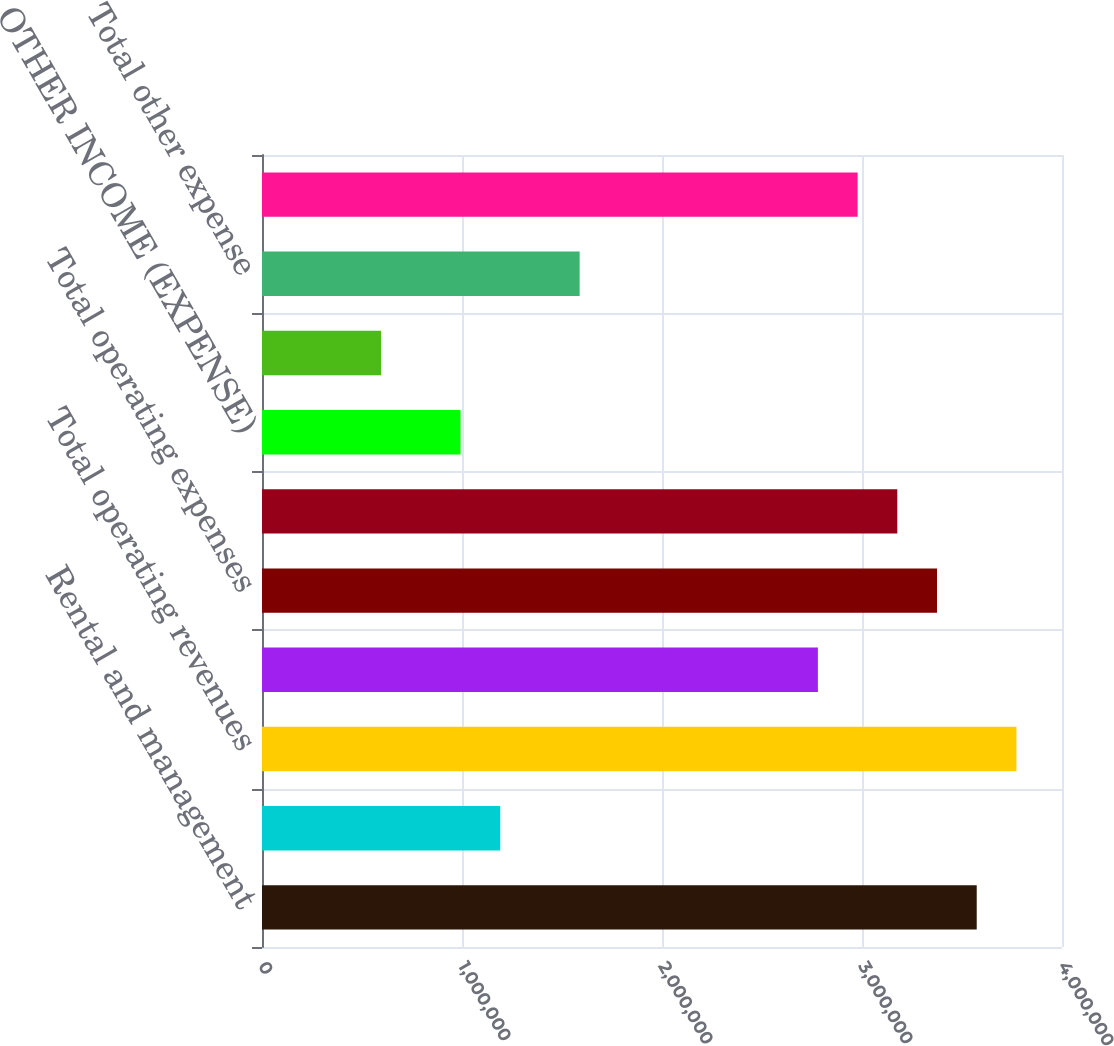<chart> <loc_0><loc_0><loc_500><loc_500><bar_chart><fcel>Rental and management<fcel>Network development services<fcel>Total operating revenues<fcel>Costs of operations (exclusive<fcel>Total operating expenses<fcel>OPERATING INCOME<fcel>OTHER INCOME (EXPENSE)<fcel>Other (expense) income<fcel>Total other expense<fcel>INCOME FROM CONTINUING<nl><fcel>3.5736e+06<fcel>1.1912e+06<fcel>3.77214e+06<fcel>2.77947e+06<fcel>3.37507e+06<fcel>3.17654e+06<fcel>992668<fcel>595601<fcel>1.58827e+06<fcel>2.978e+06<nl></chart> 